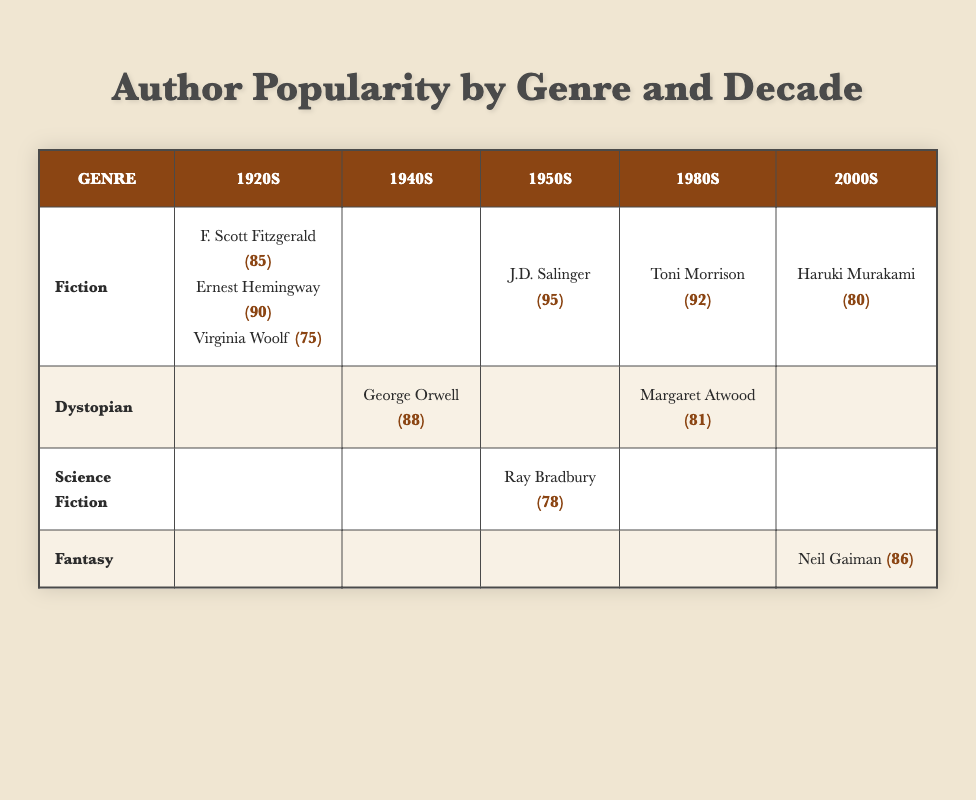What is the highest popularity score among Fiction authors in the 1920s? The table shows three authors in the Fiction genre for the 1920s: F. Scott Fitzgerald (85), Ernest Hemingway (90), and Virginia Woolf (75). Among these, the highest score is 90, from Ernest Hemingway.
Answer: 90 Which author had the lowest popularity score in Dystopian literature during the 1940s? The table lists George Orwell as the only Dystopian author in the 1940s with a popularity score of 88. Since he is the only one, he is also the lowest.
Answer: 88 What is the average popularity score of Fiction authors in the 1950s? In the 1950s, there is only one Fiction author listed, J.D. Salinger, with a popularity score of 95. Since there is no other author to average with, the score is simply 95.
Answer: 95 Did any Fiction authors have a popularity score in the 1940s? The table shows that there are no Fiction authors listed for the 1940s, confirming that no authors scored in this decade for this genre.
Answer: No Which genre had the highest recorded popularity score in the 2000s? In the 2000s, Haruki Murakami represents Fiction (80) and Neil Gaiman represents Fantasy (86). Comparing these scores, Fantasy had the highest at 86.
Answer: Fantasy What is the difference in popularity scores between the highest and lowest scored author in the 1980s? In the 1980s, the Fiction author Toni Morrison has a score of 92, and the Dystopian author Margaret Atwood has a score of 81. The difference is calculated as 92 - 81 = 11.
Answer: 11 Which genre had no authors listed in the 1920s? The table indicates that Dystopian, Science Fiction, and Fantasy genres do not have any authors listed for the 1920s, confirming these genres did not have representation during that decade.
Answer: Dystopian, Science Fiction, Fantasy Which author had a popularity score of 86 and in which genre and decade did they appear? The author with a popularity score of 86 is Neil Gaiman. He appears in the Fantasy genre during the 2000s.
Answer: Neil Gaiman, Fantasy, 2000s 